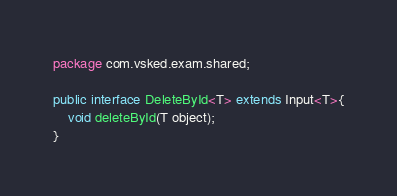Convert code to text. <code><loc_0><loc_0><loc_500><loc_500><_Java_>package com.vsked.exam.shared;

public interface DeleteById<T> extends Input<T>{
    void deleteById(T object);
}
</code> 